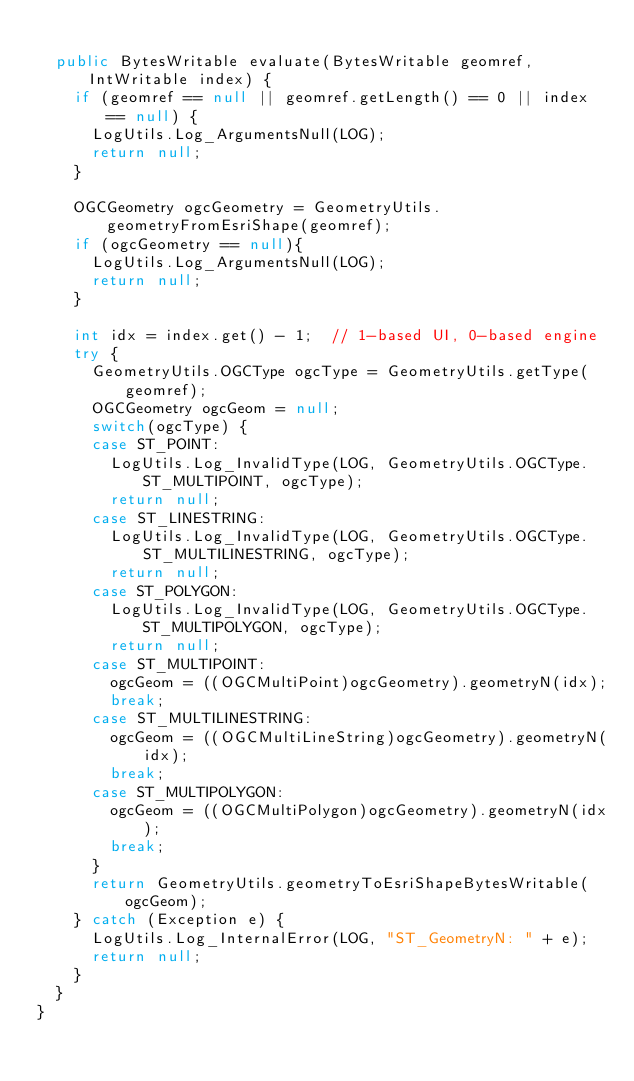<code> <loc_0><loc_0><loc_500><loc_500><_Java_>
	public BytesWritable evaluate(BytesWritable geomref, IntWritable index) {
		if (geomref == null || geomref.getLength() == 0 || index == null) {
			LogUtils.Log_ArgumentsNull(LOG);
			return null;
		}

		OGCGeometry ogcGeometry = GeometryUtils.geometryFromEsriShape(geomref);
		if (ogcGeometry == null){
			LogUtils.Log_ArgumentsNull(LOG);
			return null;
		}

		int idx = index.get() - 1;  // 1-based UI, 0-based engine
		try {
			GeometryUtils.OGCType ogcType = GeometryUtils.getType(geomref);
			OGCGeometry ogcGeom = null;
			switch(ogcType) {
			case ST_POINT:
				LogUtils.Log_InvalidType(LOG, GeometryUtils.OGCType.ST_MULTIPOINT, ogcType);
				return null;
			case ST_LINESTRING:
				LogUtils.Log_InvalidType(LOG, GeometryUtils.OGCType.ST_MULTILINESTRING, ogcType);
				return null;
			case ST_POLYGON:
				LogUtils.Log_InvalidType(LOG, GeometryUtils.OGCType.ST_MULTIPOLYGON, ogcType);
				return null;
			case ST_MULTIPOINT:
				ogcGeom = ((OGCMultiPoint)ogcGeometry).geometryN(idx);
				break;
			case ST_MULTILINESTRING:
				ogcGeom = ((OGCMultiLineString)ogcGeometry).geometryN(idx);
				break;
			case ST_MULTIPOLYGON:
				ogcGeom = ((OGCMultiPolygon)ogcGeometry).geometryN(idx);
				break;
			}
			return GeometryUtils.geometryToEsriShapeBytesWritable(ogcGeom);
		} catch (Exception e) {
			LogUtils.Log_InternalError(LOG, "ST_GeometryN: " + e);
			return null;
		}
	}
}
</code> 